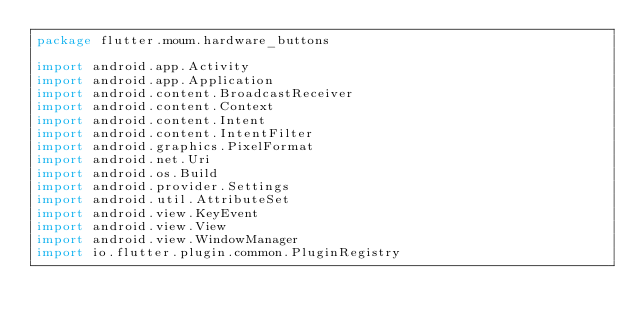<code> <loc_0><loc_0><loc_500><loc_500><_Kotlin_>package flutter.moum.hardware_buttons

import android.app.Activity
import android.app.Application
import android.content.BroadcastReceiver
import android.content.Context
import android.content.Intent
import android.content.IntentFilter
import android.graphics.PixelFormat
import android.net.Uri
import android.os.Build
import android.provider.Settings
import android.util.AttributeSet
import android.view.KeyEvent
import android.view.View
import android.view.WindowManager
import io.flutter.plugin.common.PluginRegistry

</code> 